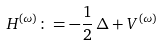<formula> <loc_0><loc_0><loc_500><loc_500>H ^ { ( \omega ) } \colon = - { \frac { 1 } { 2 } } \, \Delta + V ^ { ( \omega ) }</formula> 